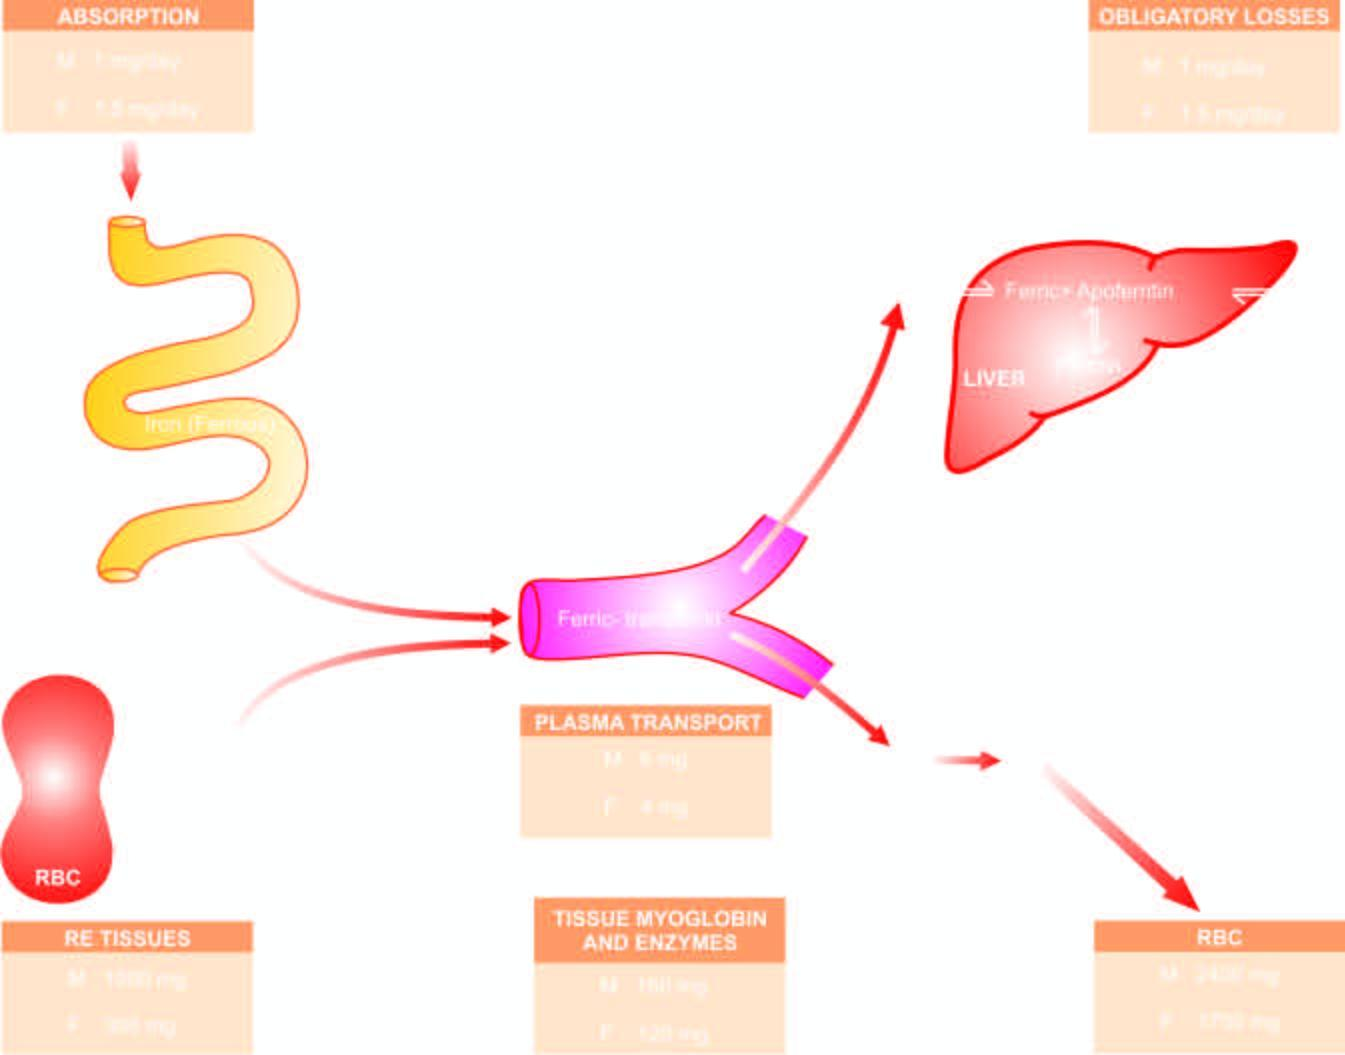s iron stored as ferritin and haemosiderin?
Answer the question using a single word or phrase. Yes 